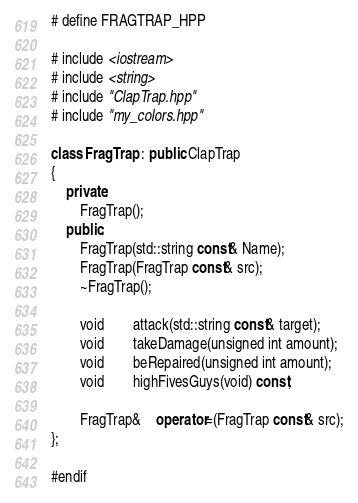<code> <loc_0><loc_0><loc_500><loc_500><_C++_># define FRAGTRAP_HPP

# include <iostream>
# include <string>
# include "ClapTrap.hpp"
# include "my_colors.hpp"

class FragTrap : public ClapTrap
{
	private:
		FragTrap();
	public:
		FragTrap(std::string const& Name);
		FragTrap(FragTrap const& src);
		~FragTrap();

		void		attack(std::string const& target);
		void		takeDamage(unsigned int amount);
		void		beRepaired(unsigned int amount);
		void		highFivesGuys(void) const;
	
		FragTrap&	operator=(FragTrap const& src);
};

#endif
</code> 